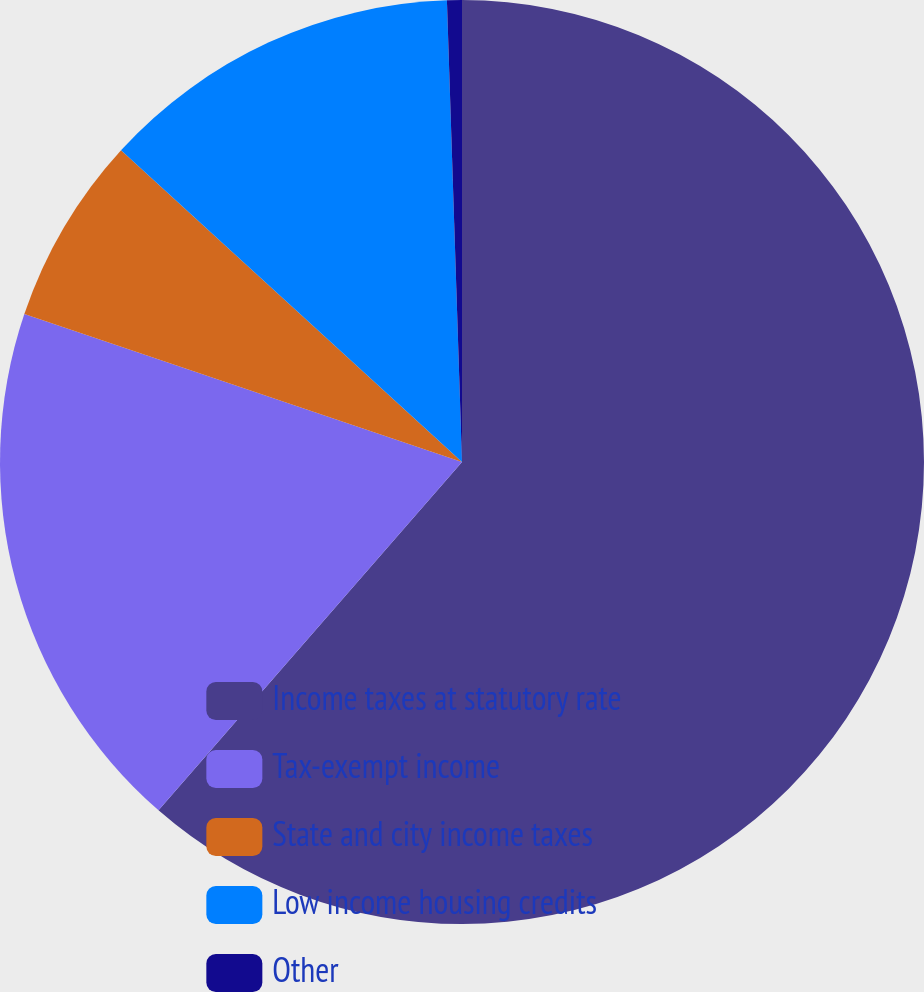<chart> <loc_0><loc_0><loc_500><loc_500><pie_chart><fcel>Income taxes at statutory rate<fcel>Tax-exempt income<fcel>State and city income taxes<fcel>Low income housing credits<fcel>Other<nl><fcel>61.4%<fcel>18.78%<fcel>6.6%<fcel>12.69%<fcel>0.52%<nl></chart> 